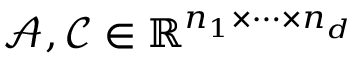<formula> <loc_0><loc_0><loc_500><loc_500>\mathcal { A } , \mathcal { C } \in \mathbb { R } ^ { n _ { 1 } \times \cdots \times n _ { d } }</formula> 